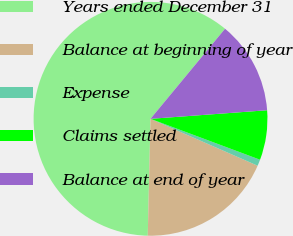<chart> <loc_0><loc_0><loc_500><loc_500><pie_chart><fcel>Years ended December 31<fcel>Balance at beginning of year<fcel>Expense<fcel>Claims settled<fcel>Balance at end of year<nl><fcel>60.63%<fcel>18.81%<fcel>0.88%<fcel>6.86%<fcel>12.83%<nl></chart> 